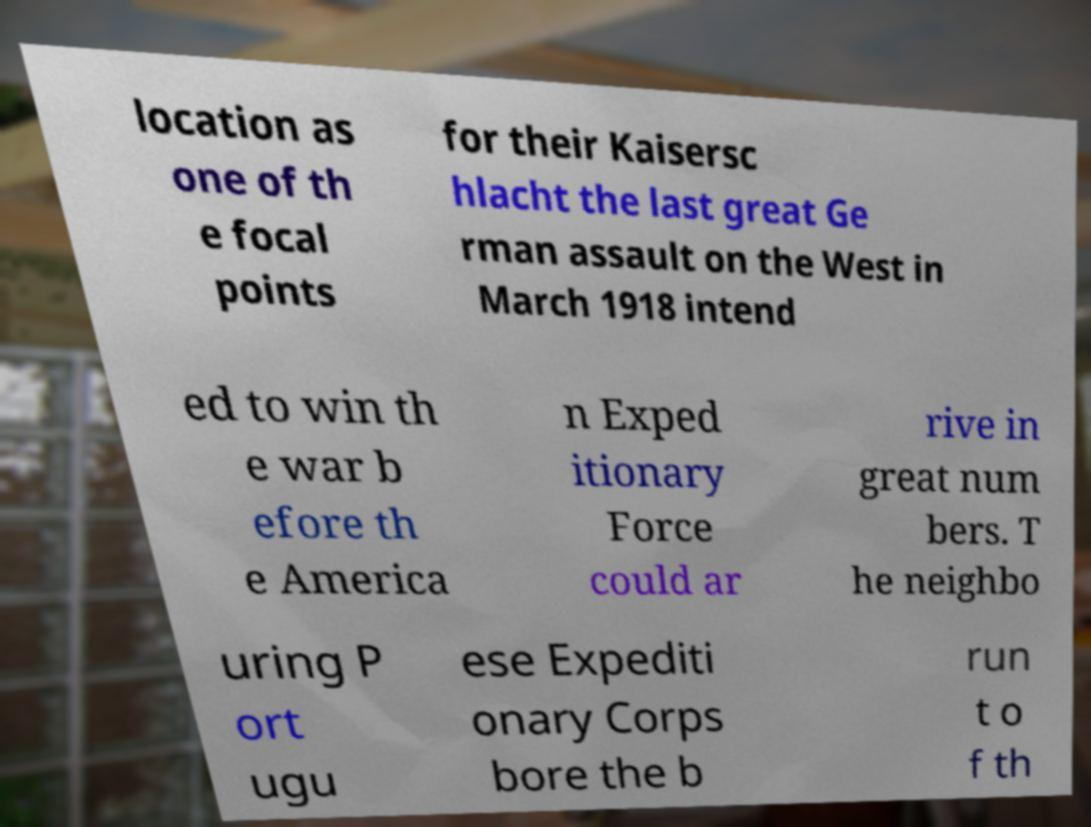Please identify and transcribe the text found in this image. location as one of th e focal points for their Kaisersc hlacht the last great Ge rman assault on the West in March 1918 intend ed to win th e war b efore th e America n Exped itionary Force could ar rive in great num bers. T he neighbo uring P ort ugu ese Expediti onary Corps bore the b run t o f th 